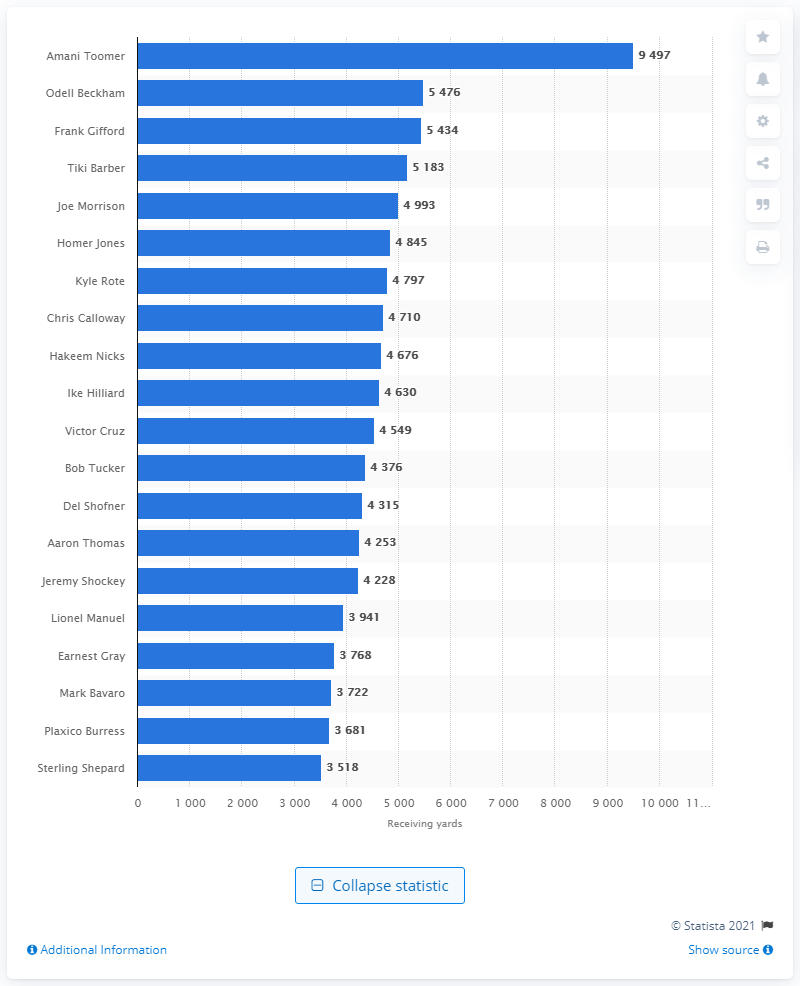Draw attention to some important aspects in this diagram. Amani Toomer is the career receiving leader of the New York Giants. 